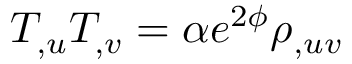<formula> <loc_0><loc_0><loc_500><loc_500>T _ { , u } T _ { , v } = \alpha e ^ { 2 \phi } \rho _ { , u v }</formula> 